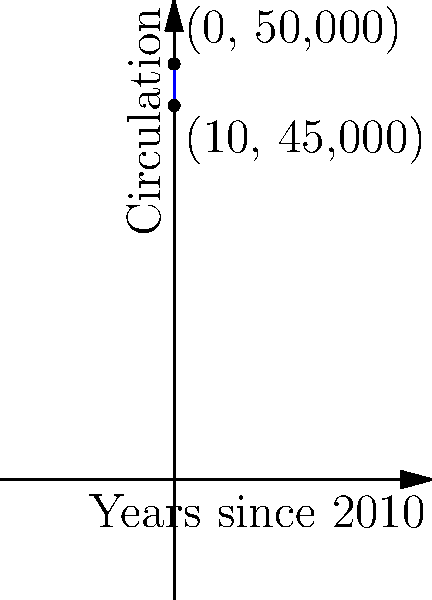As a journalist, you've been tasked with analyzing the decline in your local newspaper's circulation. The graph shows the circulation numbers from 2010 to 2020. What is the slope of the line representing this decline, and what does it signify about the yearly change in circulation? To find the slope of the line, we'll use the slope formula:

$$ m = \frac{y_2 - y_1}{x_2 - x_1} $$

Where:
$(x_1, y_1)$ is the point (0, 50,000) representing 2010
$(x_2, y_2)$ is the point (10, 45,000) representing 2020

Plugging in these values:

$$ m = \frac{45,000 - 50,000}{10 - 0} = \frac{-5,000}{10} = -500 $$

The slope is -500, which represents the average yearly decline in circulation.

To interpret this:
- The negative sign indicates a decrease in circulation over time.
- The value 500 means that, on average, the newspaper lost 500 subscribers each year between 2010 and 2020.
Answer: -500 subscribers per year 